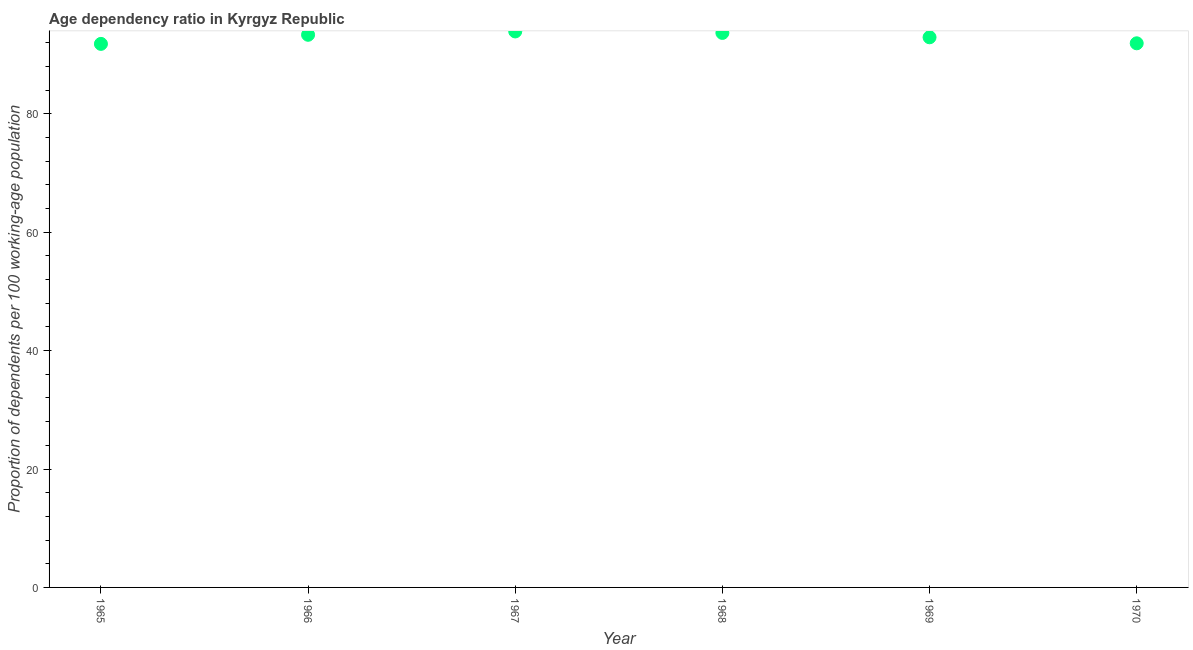What is the age dependency ratio in 1969?
Offer a terse response. 92.93. Across all years, what is the maximum age dependency ratio?
Offer a very short reply. 93.91. Across all years, what is the minimum age dependency ratio?
Your response must be concise. 91.81. In which year was the age dependency ratio maximum?
Provide a succinct answer. 1967. In which year was the age dependency ratio minimum?
Your response must be concise. 1965. What is the sum of the age dependency ratio?
Keep it short and to the point. 557.57. What is the difference between the age dependency ratio in 1965 and 1970?
Give a very brief answer. -0.1. What is the average age dependency ratio per year?
Make the answer very short. 92.93. What is the median age dependency ratio?
Keep it short and to the point. 93.14. What is the ratio of the age dependency ratio in 1965 to that in 1966?
Offer a terse response. 0.98. What is the difference between the highest and the second highest age dependency ratio?
Give a very brief answer. 0.25. Is the sum of the age dependency ratio in 1965 and 1966 greater than the maximum age dependency ratio across all years?
Keep it short and to the point. Yes. What is the difference between the highest and the lowest age dependency ratio?
Provide a short and direct response. 2.1. Does the age dependency ratio monotonically increase over the years?
Make the answer very short. No. How many dotlines are there?
Your answer should be compact. 1. How many years are there in the graph?
Offer a very short reply. 6. What is the difference between two consecutive major ticks on the Y-axis?
Offer a terse response. 20. Does the graph contain grids?
Provide a short and direct response. No. What is the title of the graph?
Provide a succinct answer. Age dependency ratio in Kyrgyz Republic. What is the label or title of the X-axis?
Offer a very short reply. Year. What is the label or title of the Y-axis?
Offer a terse response. Proportion of dependents per 100 working-age population. What is the Proportion of dependents per 100 working-age population in 1965?
Offer a very short reply. 91.81. What is the Proportion of dependents per 100 working-age population in 1966?
Your answer should be very brief. 93.35. What is the Proportion of dependents per 100 working-age population in 1967?
Keep it short and to the point. 93.91. What is the Proportion of dependents per 100 working-age population in 1968?
Offer a very short reply. 93.66. What is the Proportion of dependents per 100 working-age population in 1969?
Make the answer very short. 92.93. What is the Proportion of dependents per 100 working-age population in 1970?
Give a very brief answer. 91.91. What is the difference between the Proportion of dependents per 100 working-age population in 1965 and 1966?
Your response must be concise. -1.54. What is the difference between the Proportion of dependents per 100 working-age population in 1965 and 1967?
Provide a succinct answer. -2.1. What is the difference between the Proportion of dependents per 100 working-age population in 1965 and 1968?
Your answer should be compact. -1.85. What is the difference between the Proportion of dependents per 100 working-age population in 1965 and 1969?
Your response must be concise. -1.12. What is the difference between the Proportion of dependents per 100 working-age population in 1965 and 1970?
Provide a succinct answer. -0.1. What is the difference between the Proportion of dependents per 100 working-age population in 1966 and 1967?
Make the answer very short. -0.56. What is the difference between the Proportion of dependents per 100 working-age population in 1966 and 1968?
Offer a terse response. -0.32. What is the difference between the Proportion of dependents per 100 working-age population in 1966 and 1969?
Offer a terse response. 0.42. What is the difference between the Proportion of dependents per 100 working-age population in 1966 and 1970?
Your answer should be compact. 1.44. What is the difference between the Proportion of dependents per 100 working-age population in 1967 and 1968?
Give a very brief answer. 0.25. What is the difference between the Proportion of dependents per 100 working-age population in 1967 and 1969?
Keep it short and to the point. 0.99. What is the difference between the Proportion of dependents per 100 working-age population in 1967 and 1970?
Offer a very short reply. 2. What is the difference between the Proportion of dependents per 100 working-age population in 1968 and 1969?
Your answer should be very brief. 0.74. What is the difference between the Proportion of dependents per 100 working-age population in 1968 and 1970?
Give a very brief answer. 1.75. What is the difference between the Proportion of dependents per 100 working-age population in 1969 and 1970?
Make the answer very short. 1.02. What is the ratio of the Proportion of dependents per 100 working-age population in 1965 to that in 1967?
Make the answer very short. 0.98. What is the ratio of the Proportion of dependents per 100 working-age population in 1965 to that in 1968?
Your answer should be very brief. 0.98. What is the ratio of the Proportion of dependents per 100 working-age population in 1965 to that in 1969?
Offer a very short reply. 0.99. What is the ratio of the Proportion of dependents per 100 working-age population in 1965 to that in 1970?
Keep it short and to the point. 1. What is the ratio of the Proportion of dependents per 100 working-age population in 1966 to that in 1968?
Give a very brief answer. 1. What is the ratio of the Proportion of dependents per 100 working-age population in 1967 to that in 1968?
Offer a terse response. 1. What is the ratio of the Proportion of dependents per 100 working-age population in 1968 to that in 1969?
Provide a short and direct response. 1.01. 